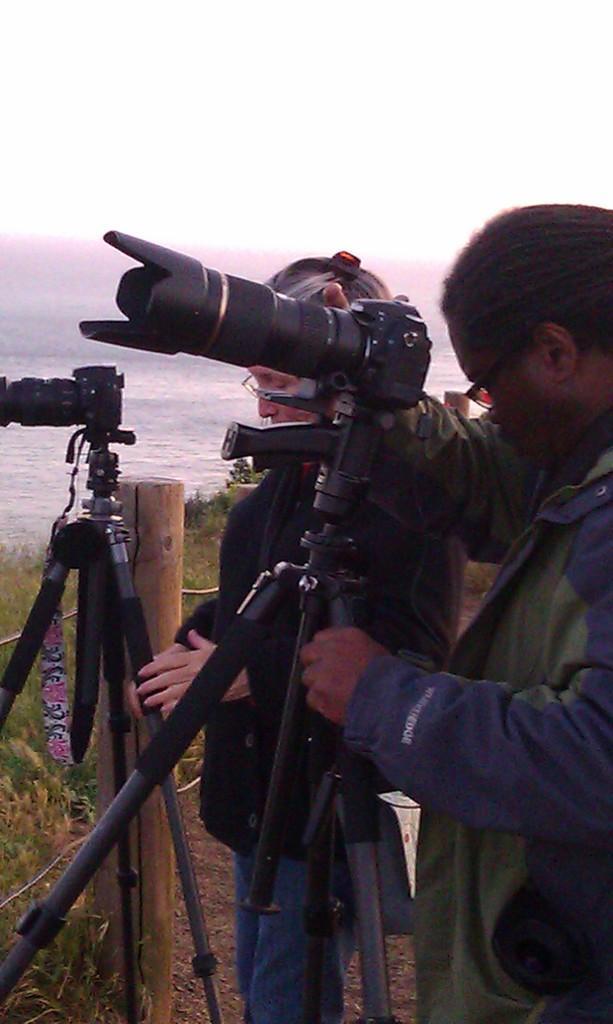How would you summarize this image in a sentence or two? In this picture there are people in the center of the image and there are two cameras in front of them and there is water in the background area of the image and there is greenery in the image. 